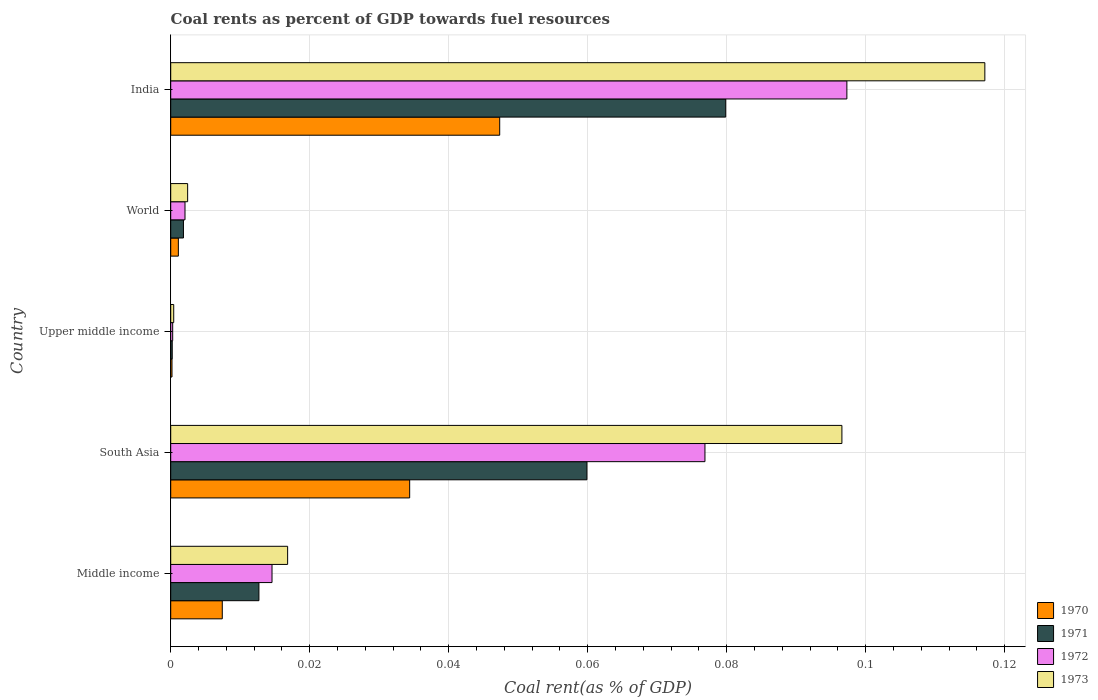Are the number of bars per tick equal to the number of legend labels?
Give a very brief answer. Yes. How many bars are there on the 2nd tick from the bottom?
Provide a short and direct response. 4. In how many cases, is the number of bars for a given country not equal to the number of legend labels?
Your response must be concise. 0. What is the coal rent in 1973 in Upper middle income?
Offer a very short reply. 0. Across all countries, what is the maximum coal rent in 1970?
Keep it short and to the point. 0.05. Across all countries, what is the minimum coal rent in 1972?
Ensure brevity in your answer.  0. In which country was the coal rent in 1972 maximum?
Give a very brief answer. India. In which country was the coal rent in 1972 minimum?
Give a very brief answer. Upper middle income. What is the total coal rent in 1970 in the graph?
Ensure brevity in your answer.  0.09. What is the difference between the coal rent in 1971 in India and that in Upper middle income?
Provide a succinct answer. 0.08. What is the difference between the coal rent in 1972 in World and the coal rent in 1970 in Upper middle income?
Your response must be concise. 0. What is the average coal rent in 1970 per country?
Offer a terse response. 0.02. What is the difference between the coal rent in 1971 and coal rent in 1973 in South Asia?
Give a very brief answer. -0.04. In how many countries, is the coal rent in 1973 greater than 0.092 %?
Your response must be concise. 2. What is the ratio of the coal rent in 1970 in South Asia to that in Upper middle income?
Your response must be concise. 187.05. Is the difference between the coal rent in 1971 in South Asia and Upper middle income greater than the difference between the coal rent in 1973 in South Asia and Upper middle income?
Offer a very short reply. No. What is the difference between the highest and the second highest coal rent in 1973?
Your answer should be very brief. 0.02. What is the difference between the highest and the lowest coal rent in 1972?
Offer a very short reply. 0.1. In how many countries, is the coal rent in 1973 greater than the average coal rent in 1973 taken over all countries?
Offer a terse response. 2. How many countries are there in the graph?
Make the answer very short. 5. What is the difference between two consecutive major ticks on the X-axis?
Your answer should be very brief. 0.02. Are the values on the major ticks of X-axis written in scientific E-notation?
Your answer should be compact. No. Does the graph contain any zero values?
Offer a terse response. No. How are the legend labels stacked?
Your response must be concise. Vertical. What is the title of the graph?
Offer a terse response. Coal rents as percent of GDP towards fuel resources. What is the label or title of the X-axis?
Offer a very short reply. Coal rent(as % of GDP). What is the label or title of the Y-axis?
Your answer should be compact. Country. What is the Coal rent(as % of GDP) in 1970 in Middle income?
Your response must be concise. 0.01. What is the Coal rent(as % of GDP) in 1971 in Middle income?
Give a very brief answer. 0.01. What is the Coal rent(as % of GDP) in 1972 in Middle income?
Provide a succinct answer. 0.01. What is the Coal rent(as % of GDP) in 1973 in Middle income?
Your answer should be very brief. 0.02. What is the Coal rent(as % of GDP) in 1970 in South Asia?
Keep it short and to the point. 0.03. What is the Coal rent(as % of GDP) in 1971 in South Asia?
Keep it short and to the point. 0.06. What is the Coal rent(as % of GDP) of 1972 in South Asia?
Provide a short and direct response. 0.08. What is the Coal rent(as % of GDP) of 1973 in South Asia?
Keep it short and to the point. 0.1. What is the Coal rent(as % of GDP) of 1970 in Upper middle income?
Provide a succinct answer. 0. What is the Coal rent(as % of GDP) in 1971 in Upper middle income?
Provide a short and direct response. 0. What is the Coal rent(as % of GDP) of 1972 in Upper middle income?
Offer a very short reply. 0. What is the Coal rent(as % of GDP) of 1973 in Upper middle income?
Your response must be concise. 0. What is the Coal rent(as % of GDP) in 1970 in World?
Your answer should be very brief. 0. What is the Coal rent(as % of GDP) of 1971 in World?
Provide a succinct answer. 0. What is the Coal rent(as % of GDP) in 1972 in World?
Provide a short and direct response. 0. What is the Coal rent(as % of GDP) in 1973 in World?
Keep it short and to the point. 0. What is the Coal rent(as % of GDP) of 1970 in India?
Offer a very short reply. 0.05. What is the Coal rent(as % of GDP) of 1971 in India?
Offer a very short reply. 0.08. What is the Coal rent(as % of GDP) of 1972 in India?
Offer a terse response. 0.1. What is the Coal rent(as % of GDP) in 1973 in India?
Keep it short and to the point. 0.12. Across all countries, what is the maximum Coal rent(as % of GDP) of 1970?
Your answer should be compact. 0.05. Across all countries, what is the maximum Coal rent(as % of GDP) of 1971?
Ensure brevity in your answer.  0.08. Across all countries, what is the maximum Coal rent(as % of GDP) of 1972?
Make the answer very short. 0.1. Across all countries, what is the maximum Coal rent(as % of GDP) in 1973?
Offer a very short reply. 0.12. Across all countries, what is the minimum Coal rent(as % of GDP) of 1970?
Offer a very short reply. 0. Across all countries, what is the minimum Coal rent(as % of GDP) in 1971?
Provide a succinct answer. 0. Across all countries, what is the minimum Coal rent(as % of GDP) in 1972?
Your response must be concise. 0. Across all countries, what is the minimum Coal rent(as % of GDP) in 1973?
Provide a succinct answer. 0. What is the total Coal rent(as % of GDP) of 1970 in the graph?
Provide a succinct answer. 0.09. What is the total Coal rent(as % of GDP) of 1971 in the graph?
Your answer should be compact. 0.15. What is the total Coal rent(as % of GDP) in 1972 in the graph?
Offer a very short reply. 0.19. What is the total Coal rent(as % of GDP) in 1973 in the graph?
Provide a succinct answer. 0.23. What is the difference between the Coal rent(as % of GDP) in 1970 in Middle income and that in South Asia?
Provide a short and direct response. -0.03. What is the difference between the Coal rent(as % of GDP) in 1971 in Middle income and that in South Asia?
Provide a short and direct response. -0.05. What is the difference between the Coal rent(as % of GDP) of 1972 in Middle income and that in South Asia?
Provide a short and direct response. -0.06. What is the difference between the Coal rent(as % of GDP) in 1973 in Middle income and that in South Asia?
Your answer should be compact. -0.08. What is the difference between the Coal rent(as % of GDP) in 1970 in Middle income and that in Upper middle income?
Offer a very short reply. 0.01. What is the difference between the Coal rent(as % of GDP) in 1971 in Middle income and that in Upper middle income?
Keep it short and to the point. 0.01. What is the difference between the Coal rent(as % of GDP) of 1972 in Middle income and that in Upper middle income?
Ensure brevity in your answer.  0.01. What is the difference between the Coal rent(as % of GDP) in 1973 in Middle income and that in Upper middle income?
Give a very brief answer. 0.02. What is the difference between the Coal rent(as % of GDP) of 1970 in Middle income and that in World?
Make the answer very short. 0.01. What is the difference between the Coal rent(as % of GDP) in 1971 in Middle income and that in World?
Make the answer very short. 0.01. What is the difference between the Coal rent(as % of GDP) in 1972 in Middle income and that in World?
Make the answer very short. 0.01. What is the difference between the Coal rent(as % of GDP) of 1973 in Middle income and that in World?
Your response must be concise. 0.01. What is the difference between the Coal rent(as % of GDP) of 1970 in Middle income and that in India?
Make the answer very short. -0.04. What is the difference between the Coal rent(as % of GDP) in 1971 in Middle income and that in India?
Your response must be concise. -0.07. What is the difference between the Coal rent(as % of GDP) of 1972 in Middle income and that in India?
Keep it short and to the point. -0.08. What is the difference between the Coal rent(as % of GDP) of 1973 in Middle income and that in India?
Keep it short and to the point. -0.1. What is the difference between the Coal rent(as % of GDP) in 1970 in South Asia and that in Upper middle income?
Make the answer very short. 0.03. What is the difference between the Coal rent(as % of GDP) of 1971 in South Asia and that in Upper middle income?
Offer a terse response. 0.06. What is the difference between the Coal rent(as % of GDP) in 1972 in South Asia and that in Upper middle income?
Provide a succinct answer. 0.08. What is the difference between the Coal rent(as % of GDP) in 1973 in South Asia and that in Upper middle income?
Provide a succinct answer. 0.1. What is the difference between the Coal rent(as % of GDP) of 1970 in South Asia and that in World?
Provide a short and direct response. 0.03. What is the difference between the Coal rent(as % of GDP) of 1971 in South Asia and that in World?
Provide a short and direct response. 0.06. What is the difference between the Coal rent(as % of GDP) in 1972 in South Asia and that in World?
Ensure brevity in your answer.  0.07. What is the difference between the Coal rent(as % of GDP) in 1973 in South Asia and that in World?
Ensure brevity in your answer.  0.09. What is the difference between the Coal rent(as % of GDP) of 1970 in South Asia and that in India?
Keep it short and to the point. -0.01. What is the difference between the Coal rent(as % of GDP) of 1971 in South Asia and that in India?
Provide a short and direct response. -0.02. What is the difference between the Coal rent(as % of GDP) in 1972 in South Asia and that in India?
Keep it short and to the point. -0.02. What is the difference between the Coal rent(as % of GDP) in 1973 in South Asia and that in India?
Your answer should be very brief. -0.02. What is the difference between the Coal rent(as % of GDP) in 1970 in Upper middle income and that in World?
Provide a short and direct response. -0. What is the difference between the Coal rent(as % of GDP) in 1971 in Upper middle income and that in World?
Give a very brief answer. -0. What is the difference between the Coal rent(as % of GDP) of 1972 in Upper middle income and that in World?
Your response must be concise. -0. What is the difference between the Coal rent(as % of GDP) of 1973 in Upper middle income and that in World?
Your answer should be compact. -0. What is the difference between the Coal rent(as % of GDP) of 1970 in Upper middle income and that in India?
Your answer should be very brief. -0.05. What is the difference between the Coal rent(as % of GDP) of 1971 in Upper middle income and that in India?
Offer a terse response. -0.08. What is the difference between the Coal rent(as % of GDP) in 1972 in Upper middle income and that in India?
Give a very brief answer. -0.1. What is the difference between the Coal rent(as % of GDP) of 1973 in Upper middle income and that in India?
Provide a short and direct response. -0.12. What is the difference between the Coal rent(as % of GDP) of 1970 in World and that in India?
Give a very brief answer. -0.05. What is the difference between the Coal rent(as % of GDP) of 1971 in World and that in India?
Keep it short and to the point. -0.08. What is the difference between the Coal rent(as % of GDP) of 1972 in World and that in India?
Offer a very short reply. -0.1. What is the difference between the Coal rent(as % of GDP) of 1973 in World and that in India?
Your response must be concise. -0.11. What is the difference between the Coal rent(as % of GDP) in 1970 in Middle income and the Coal rent(as % of GDP) in 1971 in South Asia?
Ensure brevity in your answer.  -0.05. What is the difference between the Coal rent(as % of GDP) in 1970 in Middle income and the Coal rent(as % of GDP) in 1972 in South Asia?
Provide a short and direct response. -0.07. What is the difference between the Coal rent(as % of GDP) of 1970 in Middle income and the Coal rent(as % of GDP) of 1973 in South Asia?
Provide a short and direct response. -0.09. What is the difference between the Coal rent(as % of GDP) of 1971 in Middle income and the Coal rent(as % of GDP) of 1972 in South Asia?
Keep it short and to the point. -0.06. What is the difference between the Coal rent(as % of GDP) of 1971 in Middle income and the Coal rent(as % of GDP) of 1973 in South Asia?
Make the answer very short. -0.08. What is the difference between the Coal rent(as % of GDP) of 1972 in Middle income and the Coal rent(as % of GDP) of 1973 in South Asia?
Make the answer very short. -0.08. What is the difference between the Coal rent(as % of GDP) of 1970 in Middle income and the Coal rent(as % of GDP) of 1971 in Upper middle income?
Make the answer very short. 0.01. What is the difference between the Coal rent(as % of GDP) of 1970 in Middle income and the Coal rent(as % of GDP) of 1972 in Upper middle income?
Your answer should be very brief. 0.01. What is the difference between the Coal rent(as % of GDP) in 1970 in Middle income and the Coal rent(as % of GDP) in 1973 in Upper middle income?
Your answer should be compact. 0.01. What is the difference between the Coal rent(as % of GDP) in 1971 in Middle income and the Coal rent(as % of GDP) in 1972 in Upper middle income?
Provide a succinct answer. 0.01. What is the difference between the Coal rent(as % of GDP) in 1971 in Middle income and the Coal rent(as % of GDP) in 1973 in Upper middle income?
Your answer should be very brief. 0.01. What is the difference between the Coal rent(as % of GDP) of 1972 in Middle income and the Coal rent(as % of GDP) of 1973 in Upper middle income?
Provide a succinct answer. 0.01. What is the difference between the Coal rent(as % of GDP) in 1970 in Middle income and the Coal rent(as % of GDP) in 1971 in World?
Your answer should be compact. 0.01. What is the difference between the Coal rent(as % of GDP) of 1970 in Middle income and the Coal rent(as % of GDP) of 1972 in World?
Your answer should be compact. 0.01. What is the difference between the Coal rent(as % of GDP) in 1970 in Middle income and the Coal rent(as % of GDP) in 1973 in World?
Give a very brief answer. 0.01. What is the difference between the Coal rent(as % of GDP) of 1971 in Middle income and the Coal rent(as % of GDP) of 1972 in World?
Your answer should be very brief. 0.01. What is the difference between the Coal rent(as % of GDP) in 1971 in Middle income and the Coal rent(as % of GDP) in 1973 in World?
Ensure brevity in your answer.  0.01. What is the difference between the Coal rent(as % of GDP) in 1972 in Middle income and the Coal rent(as % of GDP) in 1973 in World?
Your answer should be compact. 0.01. What is the difference between the Coal rent(as % of GDP) of 1970 in Middle income and the Coal rent(as % of GDP) of 1971 in India?
Provide a succinct answer. -0.07. What is the difference between the Coal rent(as % of GDP) in 1970 in Middle income and the Coal rent(as % of GDP) in 1972 in India?
Your answer should be compact. -0.09. What is the difference between the Coal rent(as % of GDP) of 1970 in Middle income and the Coal rent(as % of GDP) of 1973 in India?
Your response must be concise. -0.11. What is the difference between the Coal rent(as % of GDP) of 1971 in Middle income and the Coal rent(as % of GDP) of 1972 in India?
Offer a very short reply. -0.08. What is the difference between the Coal rent(as % of GDP) of 1971 in Middle income and the Coal rent(as % of GDP) of 1973 in India?
Provide a short and direct response. -0.1. What is the difference between the Coal rent(as % of GDP) of 1972 in Middle income and the Coal rent(as % of GDP) of 1973 in India?
Provide a succinct answer. -0.1. What is the difference between the Coal rent(as % of GDP) of 1970 in South Asia and the Coal rent(as % of GDP) of 1971 in Upper middle income?
Provide a short and direct response. 0.03. What is the difference between the Coal rent(as % of GDP) in 1970 in South Asia and the Coal rent(as % of GDP) in 1972 in Upper middle income?
Give a very brief answer. 0.03. What is the difference between the Coal rent(as % of GDP) in 1970 in South Asia and the Coal rent(as % of GDP) in 1973 in Upper middle income?
Provide a succinct answer. 0.03. What is the difference between the Coal rent(as % of GDP) of 1971 in South Asia and the Coal rent(as % of GDP) of 1972 in Upper middle income?
Provide a short and direct response. 0.06. What is the difference between the Coal rent(as % of GDP) in 1971 in South Asia and the Coal rent(as % of GDP) in 1973 in Upper middle income?
Offer a very short reply. 0.06. What is the difference between the Coal rent(as % of GDP) in 1972 in South Asia and the Coal rent(as % of GDP) in 1973 in Upper middle income?
Your answer should be compact. 0.08. What is the difference between the Coal rent(as % of GDP) in 1970 in South Asia and the Coal rent(as % of GDP) in 1971 in World?
Offer a terse response. 0.03. What is the difference between the Coal rent(as % of GDP) in 1970 in South Asia and the Coal rent(as % of GDP) in 1972 in World?
Your answer should be very brief. 0.03. What is the difference between the Coal rent(as % of GDP) of 1970 in South Asia and the Coal rent(as % of GDP) of 1973 in World?
Your answer should be very brief. 0.03. What is the difference between the Coal rent(as % of GDP) of 1971 in South Asia and the Coal rent(as % of GDP) of 1972 in World?
Keep it short and to the point. 0.06. What is the difference between the Coal rent(as % of GDP) of 1971 in South Asia and the Coal rent(as % of GDP) of 1973 in World?
Give a very brief answer. 0.06. What is the difference between the Coal rent(as % of GDP) of 1972 in South Asia and the Coal rent(as % of GDP) of 1973 in World?
Offer a terse response. 0.07. What is the difference between the Coal rent(as % of GDP) in 1970 in South Asia and the Coal rent(as % of GDP) in 1971 in India?
Provide a succinct answer. -0.05. What is the difference between the Coal rent(as % of GDP) of 1970 in South Asia and the Coal rent(as % of GDP) of 1972 in India?
Provide a short and direct response. -0.06. What is the difference between the Coal rent(as % of GDP) in 1970 in South Asia and the Coal rent(as % of GDP) in 1973 in India?
Your answer should be very brief. -0.08. What is the difference between the Coal rent(as % of GDP) in 1971 in South Asia and the Coal rent(as % of GDP) in 1972 in India?
Your answer should be compact. -0.04. What is the difference between the Coal rent(as % of GDP) in 1971 in South Asia and the Coal rent(as % of GDP) in 1973 in India?
Provide a short and direct response. -0.06. What is the difference between the Coal rent(as % of GDP) in 1972 in South Asia and the Coal rent(as % of GDP) in 1973 in India?
Your response must be concise. -0.04. What is the difference between the Coal rent(as % of GDP) in 1970 in Upper middle income and the Coal rent(as % of GDP) in 1971 in World?
Make the answer very short. -0. What is the difference between the Coal rent(as % of GDP) in 1970 in Upper middle income and the Coal rent(as % of GDP) in 1972 in World?
Give a very brief answer. -0. What is the difference between the Coal rent(as % of GDP) in 1970 in Upper middle income and the Coal rent(as % of GDP) in 1973 in World?
Keep it short and to the point. -0. What is the difference between the Coal rent(as % of GDP) in 1971 in Upper middle income and the Coal rent(as % of GDP) in 1972 in World?
Your answer should be very brief. -0. What is the difference between the Coal rent(as % of GDP) of 1971 in Upper middle income and the Coal rent(as % of GDP) of 1973 in World?
Offer a terse response. -0. What is the difference between the Coal rent(as % of GDP) in 1972 in Upper middle income and the Coal rent(as % of GDP) in 1973 in World?
Provide a short and direct response. -0. What is the difference between the Coal rent(as % of GDP) in 1970 in Upper middle income and the Coal rent(as % of GDP) in 1971 in India?
Offer a very short reply. -0.08. What is the difference between the Coal rent(as % of GDP) of 1970 in Upper middle income and the Coal rent(as % of GDP) of 1972 in India?
Your response must be concise. -0.1. What is the difference between the Coal rent(as % of GDP) in 1970 in Upper middle income and the Coal rent(as % of GDP) in 1973 in India?
Make the answer very short. -0.12. What is the difference between the Coal rent(as % of GDP) of 1971 in Upper middle income and the Coal rent(as % of GDP) of 1972 in India?
Offer a terse response. -0.1. What is the difference between the Coal rent(as % of GDP) of 1971 in Upper middle income and the Coal rent(as % of GDP) of 1973 in India?
Offer a very short reply. -0.12. What is the difference between the Coal rent(as % of GDP) in 1972 in Upper middle income and the Coal rent(as % of GDP) in 1973 in India?
Your response must be concise. -0.12. What is the difference between the Coal rent(as % of GDP) in 1970 in World and the Coal rent(as % of GDP) in 1971 in India?
Offer a very short reply. -0.08. What is the difference between the Coal rent(as % of GDP) of 1970 in World and the Coal rent(as % of GDP) of 1972 in India?
Keep it short and to the point. -0.1. What is the difference between the Coal rent(as % of GDP) in 1970 in World and the Coal rent(as % of GDP) in 1973 in India?
Your response must be concise. -0.12. What is the difference between the Coal rent(as % of GDP) in 1971 in World and the Coal rent(as % of GDP) in 1972 in India?
Your answer should be very brief. -0.1. What is the difference between the Coal rent(as % of GDP) of 1971 in World and the Coal rent(as % of GDP) of 1973 in India?
Keep it short and to the point. -0.12. What is the difference between the Coal rent(as % of GDP) in 1972 in World and the Coal rent(as % of GDP) in 1973 in India?
Ensure brevity in your answer.  -0.12. What is the average Coal rent(as % of GDP) of 1970 per country?
Keep it short and to the point. 0.02. What is the average Coal rent(as % of GDP) in 1971 per country?
Offer a very short reply. 0.03. What is the average Coal rent(as % of GDP) of 1972 per country?
Your answer should be compact. 0.04. What is the average Coal rent(as % of GDP) in 1973 per country?
Keep it short and to the point. 0.05. What is the difference between the Coal rent(as % of GDP) in 1970 and Coal rent(as % of GDP) in 1971 in Middle income?
Ensure brevity in your answer.  -0.01. What is the difference between the Coal rent(as % of GDP) in 1970 and Coal rent(as % of GDP) in 1972 in Middle income?
Offer a terse response. -0.01. What is the difference between the Coal rent(as % of GDP) in 1970 and Coal rent(as % of GDP) in 1973 in Middle income?
Your answer should be compact. -0.01. What is the difference between the Coal rent(as % of GDP) in 1971 and Coal rent(as % of GDP) in 1972 in Middle income?
Ensure brevity in your answer.  -0. What is the difference between the Coal rent(as % of GDP) in 1971 and Coal rent(as % of GDP) in 1973 in Middle income?
Ensure brevity in your answer.  -0. What is the difference between the Coal rent(as % of GDP) of 1972 and Coal rent(as % of GDP) of 1973 in Middle income?
Provide a succinct answer. -0. What is the difference between the Coal rent(as % of GDP) of 1970 and Coal rent(as % of GDP) of 1971 in South Asia?
Make the answer very short. -0.03. What is the difference between the Coal rent(as % of GDP) of 1970 and Coal rent(as % of GDP) of 1972 in South Asia?
Offer a very short reply. -0.04. What is the difference between the Coal rent(as % of GDP) of 1970 and Coal rent(as % of GDP) of 1973 in South Asia?
Provide a short and direct response. -0.06. What is the difference between the Coal rent(as % of GDP) of 1971 and Coal rent(as % of GDP) of 1972 in South Asia?
Provide a succinct answer. -0.02. What is the difference between the Coal rent(as % of GDP) in 1971 and Coal rent(as % of GDP) in 1973 in South Asia?
Keep it short and to the point. -0.04. What is the difference between the Coal rent(as % of GDP) in 1972 and Coal rent(as % of GDP) in 1973 in South Asia?
Keep it short and to the point. -0.02. What is the difference between the Coal rent(as % of GDP) in 1970 and Coal rent(as % of GDP) in 1972 in Upper middle income?
Provide a succinct answer. -0. What is the difference between the Coal rent(as % of GDP) in 1970 and Coal rent(as % of GDP) in 1973 in Upper middle income?
Provide a short and direct response. -0. What is the difference between the Coal rent(as % of GDP) of 1971 and Coal rent(as % of GDP) of 1972 in Upper middle income?
Provide a short and direct response. -0. What is the difference between the Coal rent(as % of GDP) of 1971 and Coal rent(as % of GDP) of 1973 in Upper middle income?
Provide a short and direct response. -0. What is the difference between the Coal rent(as % of GDP) of 1972 and Coal rent(as % of GDP) of 1973 in Upper middle income?
Offer a terse response. -0. What is the difference between the Coal rent(as % of GDP) of 1970 and Coal rent(as % of GDP) of 1971 in World?
Ensure brevity in your answer.  -0. What is the difference between the Coal rent(as % of GDP) of 1970 and Coal rent(as % of GDP) of 1972 in World?
Offer a terse response. -0. What is the difference between the Coal rent(as % of GDP) in 1970 and Coal rent(as % of GDP) in 1973 in World?
Offer a very short reply. -0. What is the difference between the Coal rent(as % of GDP) of 1971 and Coal rent(as % of GDP) of 1972 in World?
Make the answer very short. -0. What is the difference between the Coal rent(as % of GDP) in 1971 and Coal rent(as % of GDP) in 1973 in World?
Offer a terse response. -0. What is the difference between the Coal rent(as % of GDP) in 1972 and Coal rent(as % of GDP) in 1973 in World?
Give a very brief answer. -0. What is the difference between the Coal rent(as % of GDP) in 1970 and Coal rent(as % of GDP) in 1971 in India?
Give a very brief answer. -0.03. What is the difference between the Coal rent(as % of GDP) in 1970 and Coal rent(as % of GDP) in 1973 in India?
Offer a terse response. -0.07. What is the difference between the Coal rent(as % of GDP) in 1971 and Coal rent(as % of GDP) in 1972 in India?
Provide a short and direct response. -0.02. What is the difference between the Coal rent(as % of GDP) in 1971 and Coal rent(as % of GDP) in 1973 in India?
Offer a very short reply. -0.04. What is the difference between the Coal rent(as % of GDP) in 1972 and Coal rent(as % of GDP) in 1973 in India?
Your response must be concise. -0.02. What is the ratio of the Coal rent(as % of GDP) in 1970 in Middle income to that in South Asia?
Ensure brevity in your answer.  0.22. What is the ratio of the Coal rent(as % of GDP) of 1971 in Middle income to that in South Asia?
Ensure brevity in your answer.  0.21. What is the ratio of the Coal rent(as % of GDP) in 1972 in Middle income to that in South Asia?
Offer a terse response. 0.19. What is the ratio of the Coal rent(as % of GDP) of 1973 in Middle income to that in South Asia?
Provide a succinct answer. 0.17. What is the ratio of the Coal rent(as % of GDP) in 1970 in Middle income to that in Upper middle income?
Ensure brevity in your answer.  40.36. What is the ratio of the Coal rent(as % of GDP) of 1971 in Middle income to that in Upper middle income?
Offer a very short reply. 58.01. What is the ratio of the Coal rent(as % of GDP) in 1972 in Middle income to that in Upper middle income?
Offer a very short reply. 51.25. What is the ratio of the Coal rent(as % of GDP) of 1973 in Middle income to that in Upper middle income?
Keep it short and to the point. 39.04. What is the ratio of the Coal rent(as % of GDP) of 1970 in Middle income to that in World?
Provide a short and direct response. 6.74. What is the ratio of the Coal rent(as % of GDP) in 1971 in Middle income to that in World?
Your answer should be compact. 6.93. What is the ratio of the Coal rent(as % of GDP) of 1972 in Middle income to that in World?
Provide a succinct answer. 7.09. What is the ratio of the Coal rent(as % of GDP) of 1973 in Middle income to that in World?
Your answer should be compact. 6.91. What is the ratio of the Coal rent(as % of GDP) in 1970 in Middle income to that in India?
Provide a short and direct response. 0.16. What is the ratio of the Coal rent(as % of GDP) of 1971 in Middle income to that in India?
Offer a terse response. 0.16. What is the ratio of the Coal rent(as % of GDP) of 1972 in Middle income to that in India?
Provide a short and direct response. 0.15. What is the ratio of the Coal rent(as % of GDP) of 1973 in Middle income to that in India?
Your answer should be compact. 0.14. What is the ratio of the Coal rent(as % of GDP) in 1970 in South Asia to that in Upper middle income?
Ensure brevity in your answer.  187.05. What is the ratio of the Coal rent(as % of GDP) in 1971 in South Asia to that in Upper middle income?
Your answer should be compact. 273.74. What is the ratio of the Coal rent(as % of GDP) of 1972 in South Asia to that in Upper middle income?
Your response must be concise. 270.32. What is the ratio of the Coal rent(as % of GDP) in 1973 in South Asia to that in Upper middle income?
Your answer should be very brief. 224.18. What is the ratio of the Coal rent(as % of GDP) of 1970 in South Asia to that in World?
Give a very brief answer. 31.24. What is the ratio of the Coal rent(as % of GDP) of 1971 in South Asia to that in World?
Your response must be concise. 32.69. What is the ratio of the Coal rent(as % of GDP) in 1972 in South Asia to that in World?
Your answer should be very brief. 37.41. What is the ratio of the Coal rent(as % of GDP) in 1973 in South Asia to that in World?
Ensure brevity in your answer.  39.65. What is the ratio of the Coal rent(as % of GDP) of 1970 in South Asia to that in India?
Provide a succinct answer. 0.73. What is the ratio of the Coal rent(as % of GDP) of 1971 in South Asia to that in India?
Ensure brevity in your answer.  0.75. What is the ratio of the Coal rent(as % of GDP) of 1972 in South Asia to that in India?
Offer a very short reply. 0.79. What is the ratio of the Coal rent(as % of GDP) in 1973 in South Asia to that in India?
Your answer should be very brief. 0.82. What is the ratio of the Coal rent(as % of GDP) in 1970 in Upper middle income to that in World?
Your answer should be very brief. 0.17. What is the ratio of the Coal rent(as % of GDP) of 1971 in Upper middle income to that in World?
Offer a very short reply. 0.12. What is the ratio of the Coal rent(as % of GDP) in 1972 in Upper middle income to that in World?
Ensure brevity in your answer.  0.14. What is the ratio of the Coal rent(as % of GDP) in 1973 in Upper middle income to that in World?
Offer a terse response. 0.18. What is the ratio of the Coal rent(as % of GDP) in 1970 in Upper middle income to that in India?
Provide a short and direct response. 0. What is the ratio of the Coal rent(as % of GDP) in 1971 in Upper middle income to that in India?
Offer a terse response. 0. What is the ratio of the Coal rent(as % of GDP) in 1972 in Upper middle income to that in India?
Ensure brevity in your answer.  0. What is the ratio of the Coal rent(as % of GDP) in 1973 in Upper middle income to that in India?
Offer a very short reply. 0. What is the ratio of the Coal rent(as % of GDP) of 1970 in World to that in India?
Provide a succinct answer. 0.02. What is the ratio of the Coal rent(as % of GDP) in 1971 in World to that in India?
Offer a very short reply. 0.02. What is the ratio of the Coal rent(as % of GDP) of 1972 in World to that in India?
Make the answer very short. 0.02. What is the ratio of the Coal rent(as % of GDP) in 1973 in World to that in India?
Ensure brevity in your answer.  0.02. What is the difference between the highest and the second highest Coal rent(as % of GDP) of 1970?
Give a very brief answer. 0.01. What is the difference between the highest and the second highest Coal rent(as % of GDP) of 1972?
Provide a succinct answer. 0.02. What is the difference between the highest and the second highest Coal rent(as % of GDP) in 1973?
Offer a very short reply. 0.02. What is the difference between the highest and the lowest Coal rent(as % of GDP) of 1970?
Your answer should be very brief. 0.05. What is the difference between the highest and the lowest Coal rent(as % of GDP) of 1971?
Offer a very short reply. 0.08. What is the difference between the highest and the lowest Coal rent(as % of GDP) of 1972?
Give a very brief answer. 0.1. What is the difference between the highest and the lowest Coal rent(as % of GDP) of 1973?
Your response must be concise. 0.12. 